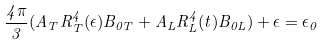Convert formula to latex. <formula><loc_0><loc_0><loc_500><loc_500>\frac { 4 \pi } { 3 } ( A _ { T } R _ { T } ^ { 4 } ( \epsilon ) B _ { 0 T } + A _ { L } R _ { L } ^ { 4 } ( t ) B _ { 0 L } ) + \epsilon = \epsilon _ { 0 }</formula> 